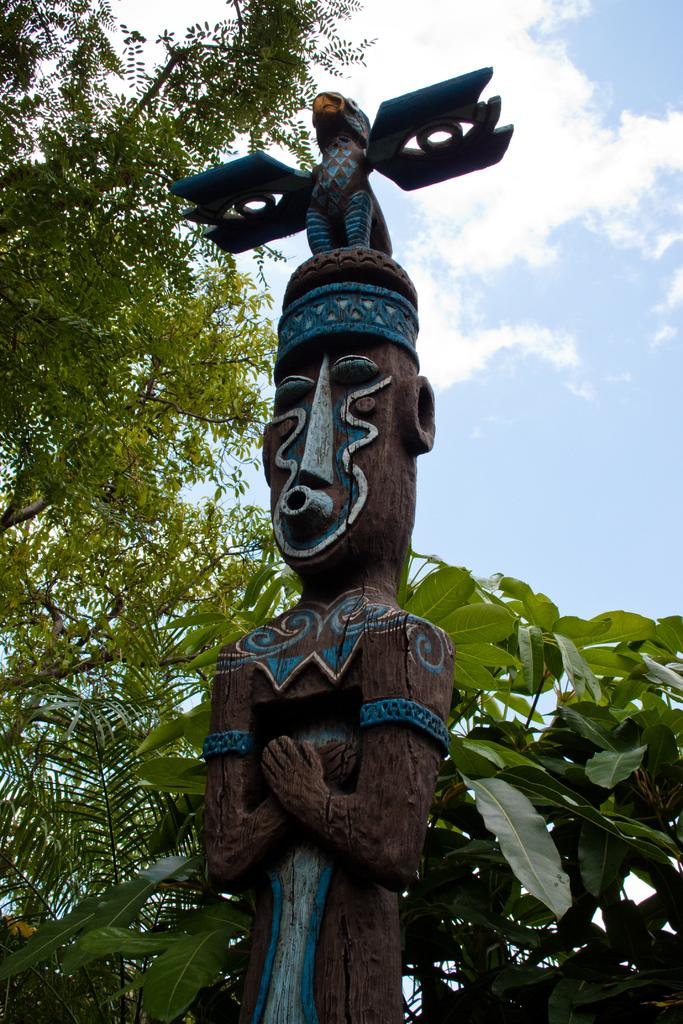What is the main subject of the image? There is a wood carving of a statue in the image. What can be seen behind the statue? There are trees visible on the backside of the statue. How would you describe the sky in the image? The sky in the image looks cloudy. Where is the mailbox located in the image? There is no mailbox present in the image. What type of vegetable is growing near the statue in the image? There are no vegetables visible in the image; only trees are mentioned. 